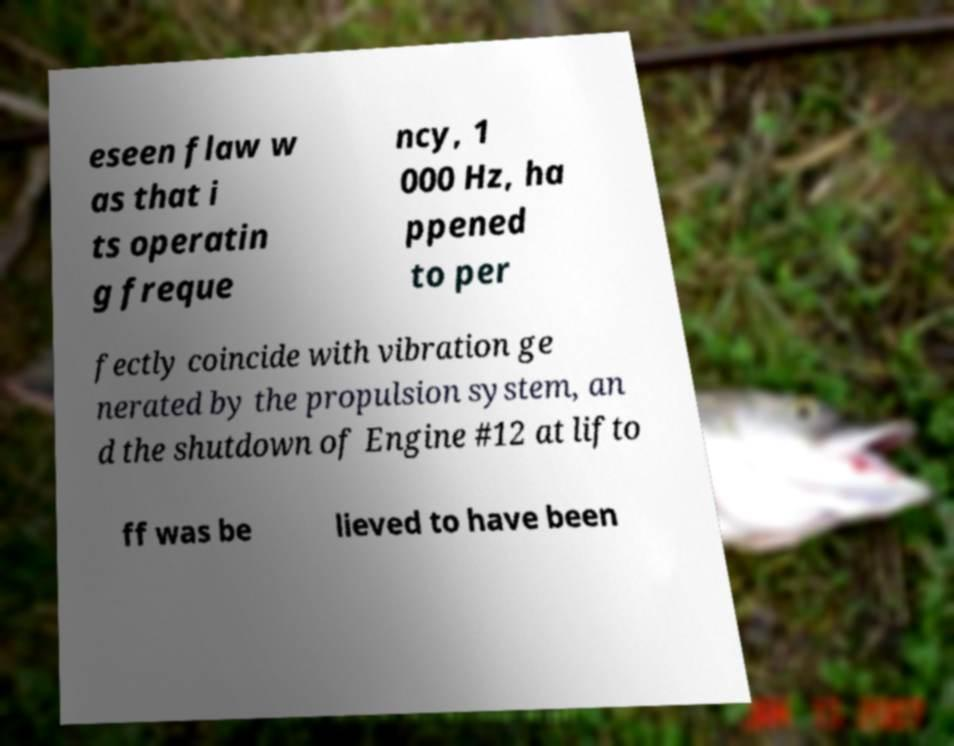What messages or text are displayed in this image? I need them in a readable, typed format. eseen flaw w as that i ts operatin g freque ncy, 1 000 Hz, ha ppened to per fectly coincide with vibration ge nerated by the propulsion system, an d the shutdown of Engine #12 at lifto ff was be lieved to have been 